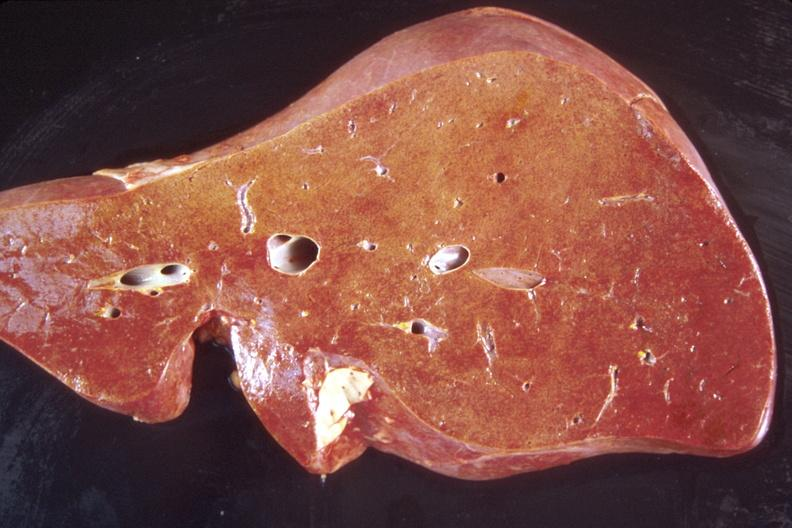does hemorrhage in newborn show liver, normal?
Answer the question using a single word or phrase. No 